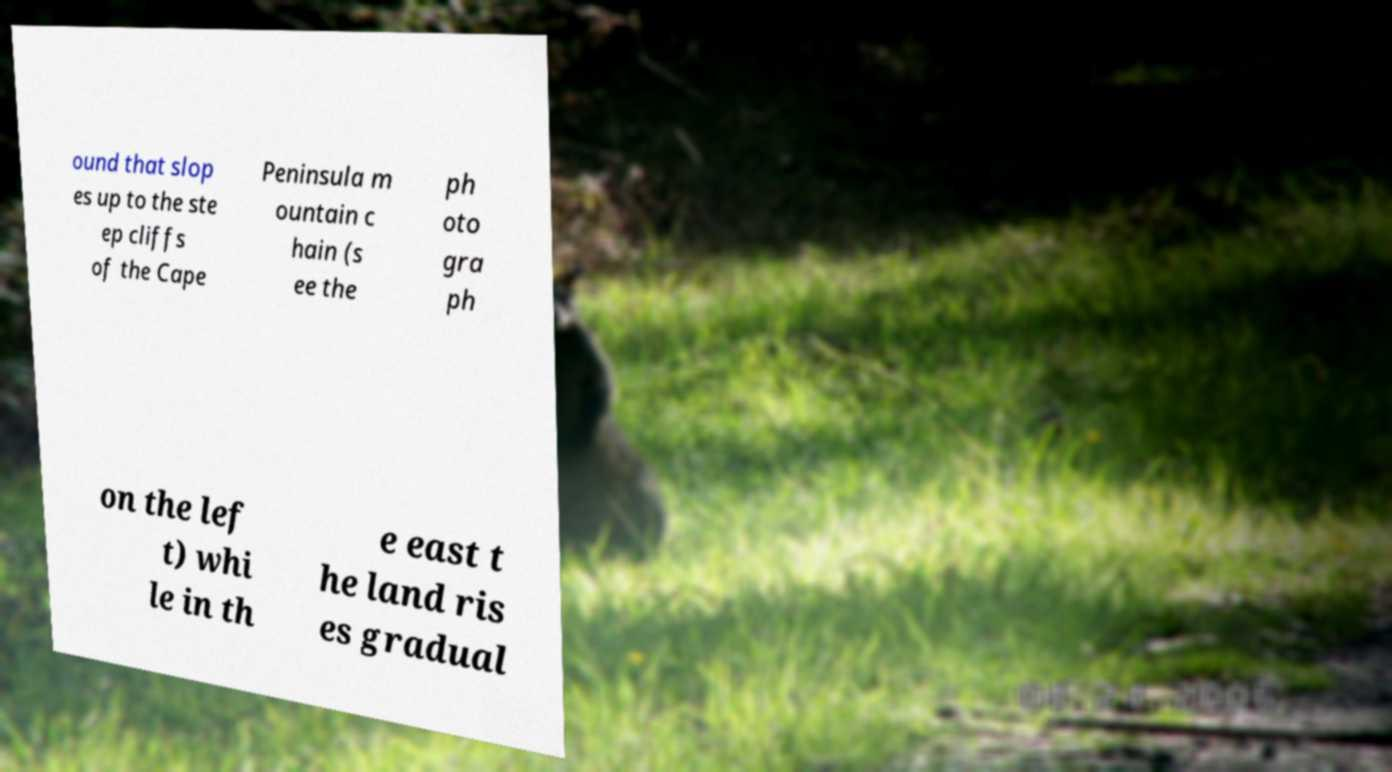I need the written content from this picture converted into text. Can you do that? ound that slop es up to the ste ep cliffs of the Cape Peninsula m ountain c hain (s ee the ph oto gra ph on the lef t) whi le in th e east t he land ris es gradual 